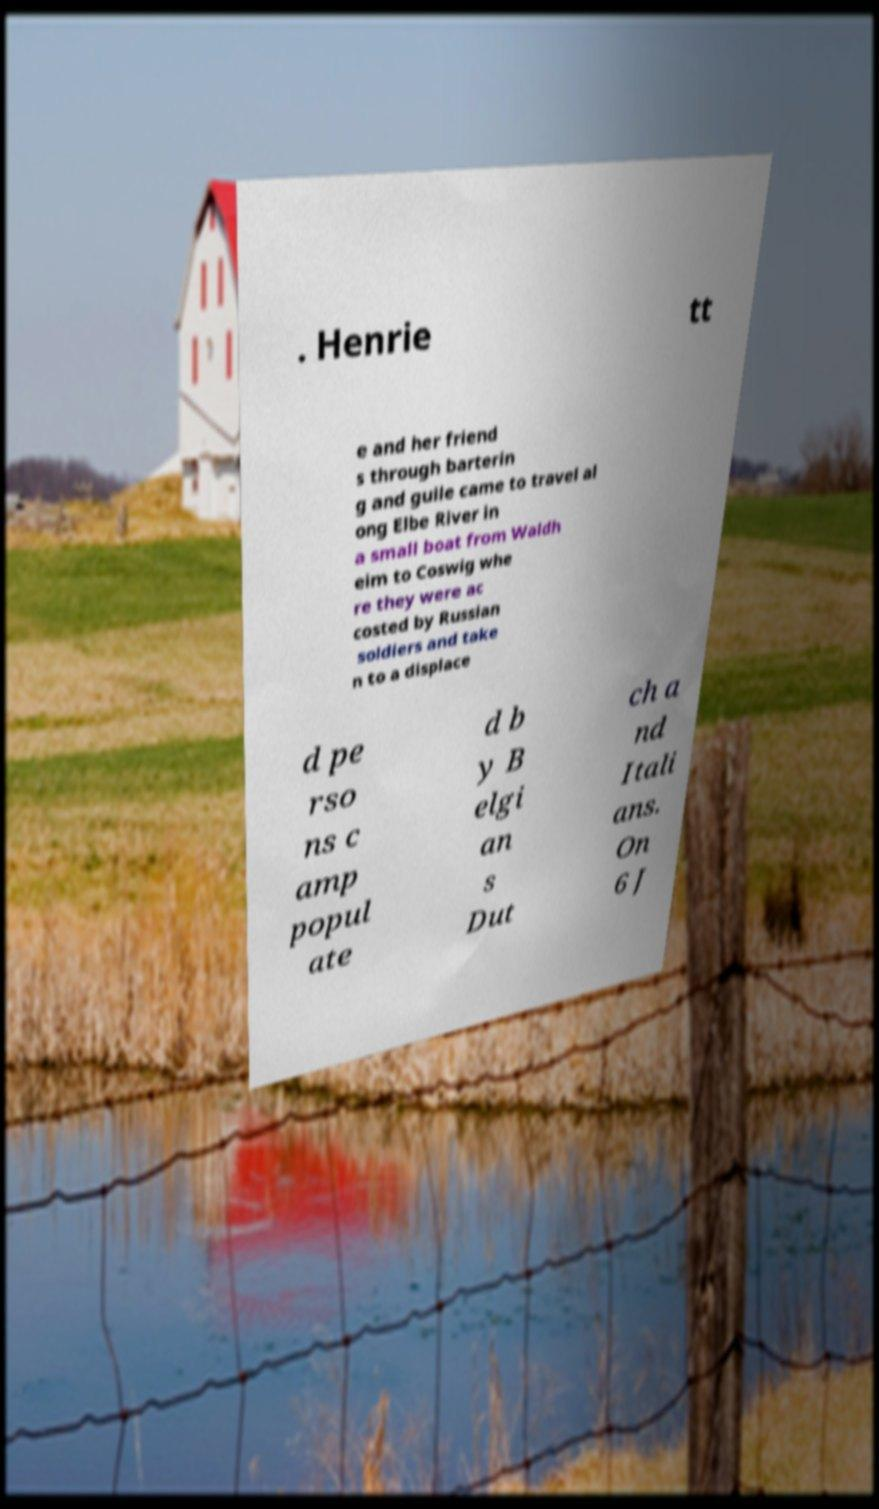Could you assist in decoding the text presented in this image and type it out clearly? . Henrie tt e and her friend s through barterin g and guile came to travel al ong Elbe River in a small boat from Waldh eim to Coswig whe re they were ac costed by Russian soldiers and take n to a displace d pe rso ns c amp popul ate d b y B elgi an s Dut ch a nd Itali ans. On 6 J 